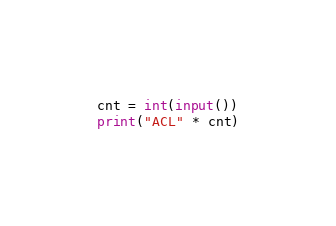Convert code to text. <code><loc_0><loc_0><loc_500><loc_500><_Python_>cnt = int(input())
print("ACL" * cnt)</code> 